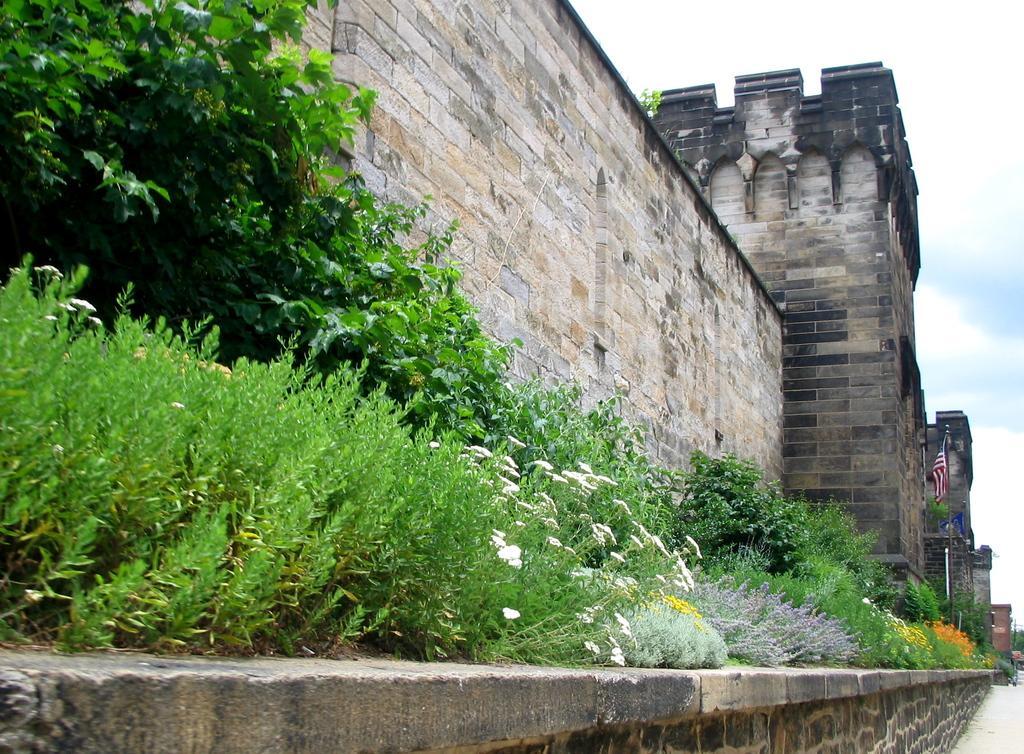How would you summarize this image in a sentence or two? In this image I can see a building and in the front I can see number of plants and number of flowers. On the right side of the image I can see a flag and a path. On the top right side of the image I can see clouds and the sky. 